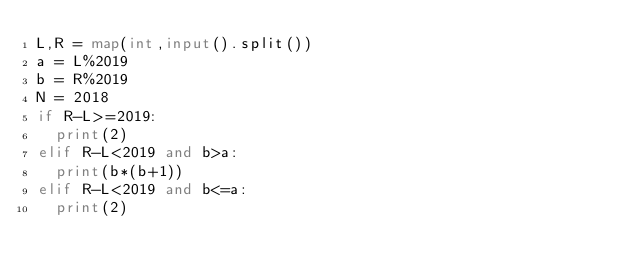<code> <loc_0><loc_0><loc_500><loc_500><_Python_>L,R = map(int,input().split())
a = L%2019
b = R%2019
N = 2018
if R-L>=2019:
  print(2)
elif R-L<2019 and b>a:
  print(b*(b+1))
elif R-L<2019 and b<=a:
  print(2)</code> 